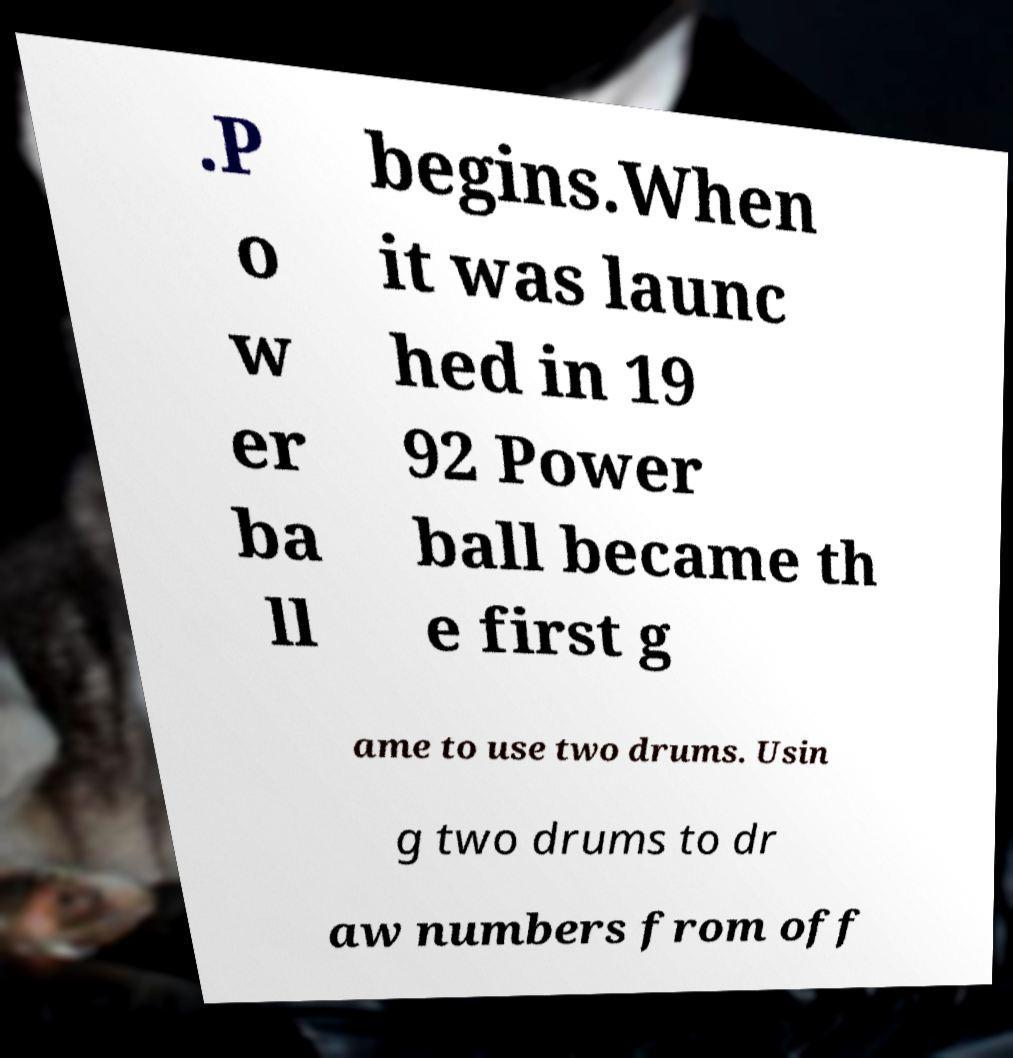For documentation purposes, I need the text within this image transcribed. Could you provide that? .P o w er ba ll begins.When it was launc hed in 19 92 Power ball became th e first g ame to use two drums. Usin g two drums to dr aw numbers from off 